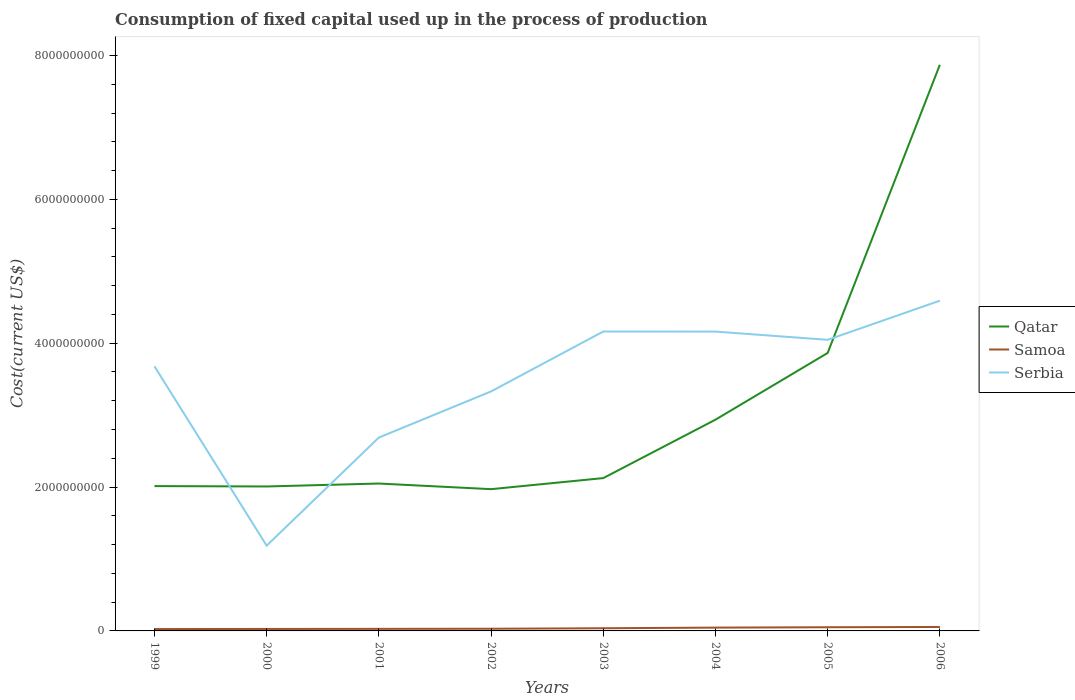Is the number of lines equal to the number of legend labels?
Make the answer very short. Yes. Across all years, what is the maximum amount consumed in the process of production in Samoa?
Offer a very short reply. 2.60e+07. In which year was the amount consumed in the process of production in Qatar maximum?
Make the answer very short. 2002. What is the total amount consumed in the process of production in Qatar in the graph?
Give a very brief answer. 4.26e+07. What is the difference between the highest and the second highest amount consumed in the process of production in Samoa?
Provide a succinct answer. 2.90e+07. What is the difference between the highest and the lowest amount consumed in the process of production in Serbia?
Keep it short and to the point. 5. Is the amount consumed in the process of production in Samoa strictly greater than the amount consumed in the process of production in Serbia over the years?
Provide a short and direct response. Yes. How many years are there in the graph?
Give a very brief answer. 8. Are the values on the major ticks of Y-axis written in scientific E-notation?
Your answer should be very brief. No. What is the title of the graph?
Give a very brief answer. Consumption of fixed capital used up in the process of production. Does "Ukraine" appear as one of the legend labels in the graph?
Your answer should be compact. No. What is the label or title of the Y-axis?
Give a very brief answer. Cost(current US$). What is the Cost(current US$) of Qatar in 1999?
Offer a very short reply. 2.01e+09. What is the Cost(current US$) in Samoa in 1999?
Your answer should be very brief. 2.60e+07. What is the Cost(current US$) in Serbia in 1999?
Offer a very short reply. 3.68e+09. What is the Cost(current US$) of Qatar in 2000?
Your response must be concise. 2.01e+09. What is the Cost(current US$) of Samoa in 2000?
Offer a terse response. 2.71e+07. What is the Cost(current US$) in Serbia in 2000?
Your response must be concise. 1.19e+09. What is the Cost(current US$) in Qatar in 2001?
Offer a terse response. 2.05e+09. What is the Cost(current US$) of Samoa in 2001?
Provide a succinct answer. 2.86e+07. What is the Cost(current US$) in Serbia in 2001?
Offer a terse response. 2.69e+09. What is the Cost(current US$) in Qatar in 2002?
Provide a short and direct response. 1.97e+09. What is the Cost(current US$) of Samoa in 2002?
Ensure brevity in your answer.  3.05e+07. What is the Cost(current US$) in Serbia in 2002?
Your response must be concise. 3.33e+09. What is the Cost(current US$) of Qatar in 2003?
Your response must be concise. 2.12e+09. What is the Cost(current US$) in Samoa in 2003?
Keep it short and to the point. 3.71e+07. What is the Cost(current US$) in Serbia in 2003?
Offer a terse response. 4.16e+09. What is the Cost(current US$) of Qatar in 2004?
Ensure brevity in your answer.  2.94e+09. What is the Cost(current US$) in Samoa in 2004?
Give a very brief answer. 4.61e+07. What is the Cost(current US$) in Serbia in 2004?
Provide a short and direct response. 4.16e+09. What is the Cost(current US$) of Qatar in 2005?
Offer a very short reply. 3.86e+09. What is the Cost(current US$) in Samoa in 2005?
Provide a succinct answer. 5.10e+07. What is the Cost(current US$) in Serbia in 2005?
Provide a short and direct response. 4.05e+09. What is the Cost(current US$) of Qatar in 2006?
Your answer should be compact. 7.87e+09. What is the Cost(current US$) of Samoa in 2006?
Your answer should be compact. 5.49e+07. What is the Cost(current US$) of Serbia in 2006?
Your answer should be very brief. 4.59e+09. Across all years, what is the maximum Cost(current US$) in Qatar?
Offer a very short reply. 7.87e+09. Across all years, what is the maximum Cost(current US$) of Samoa?
Ensure brevity in your answer.  5.49e+07. Across all years, what is the maximum Cost(current US$) in Serbia?
Make the answer very short. 4.59e+09. Across all years, what is the minimum Cost(current US$) of Qatar?
Give a very brief answer. 1.97e+09. Across all years, what is the minimum Cost(current US$) of Samoa?
Keep it short and to the point. 2.60e+07. Across all years, what is the minimum Cost(current US$) in Serbia?
Offer a very short reply. 1.19e+09. What is the total Cost(current US$) in Qatar in the graph?
Provide a succinct answer. 2.48e+1. What is the total Cost(current US$) of Samoa in the graph?
Provide a succinct answer. 3.01e+08. What is the total Cost(current US$) of Serbia in the graph?
Ensure brevity in your answer.  2.78e+1. What is the difference between the Cost(current US$) of Qatar in 1999 and that in 2000?
Give a very brief answer. 5.22e+06. What is the difference between the Cost(current US$) of Samoa in 1999 and that in 2000?
Ensure brevity in your answer.  -1.17e+06. What is the difference between the Cost(current US$) in Serbia in 1999 and that in 2000?
Make the answer very short. 2.49e+09. What is the difference between the Cost(current US$) of Qatar in 1999 and that in 2001?
Make the answer very short. -3.57e+07. What is the difference between the Cost(current US$) in Samoa in 1999 and that in 2001?
Your response must be concise. -2.62e+06. What is the difference between the Cost(current US$) in Serbia in 1999 and that in 2001?
Offer a terse response. 9.90e+08. What is the difference between the Cost(current US$) in Qatar in 1999 and that in 2002?
Offer a very short reply. 4.26e+07. What is the difference between the Cost(current US$) of Samoa in 1999 and that in 2002?
Your answer should be very brief. -4.53e+06. What is the difference between the Cost(current US$) in Serbia in 1999 and that in 2002?
Your response must be concise. 3.50e+08. What is the difference between the Cost(current US$) in Qatar in 1999 and that in 2003?
Provide a succinct answer. -1.11e+08. What is the difference between the Cost(current US$) in Samoa in 1999 and that in 2003?
Offer a very short reply. -1.11e+07. What is the difference between the Cost(current US$) of Serbia in 1999 and that in 2003?
Provide a short and direct response. -4.84e+08. What is the difference between the Cost(current US$) of Qatar in 1999 and that in 2004?
Give a very brief answer. -9.23e+08. What is the difference between the Cost(current US$) in Samoa in 1999 and that in 2004?
Give a very brief answer. -2.02e+07. What is the difference between the Cost(current US$) of Serbia in 1999 and that in 2004?
Make the answer very short. -4.83e+08. What is the difference between the Cost(current US$) of Qatar in 1999 and that in 2005?
Offer a very short reply. -1.85e+09. What is the difference between the Cost(current US$) of Samoa in 1999 and that in 2005?
Make the answer very short. -2.51e+07. What is the difference between the Cost(current US$) of Serbia in 1999 and that in 2005?
Ensure brevity in your answer.  -3.68e+08. What is the difference between the Cost(current US$) of Qatar in 1999 and that in 2006?
Offer a very short reply. -5.86e+09. What is the difference between the Cost(current US$) in Samoa in 1999 and that in 2006?
Give a very brief answer. -2.90e+07. What is the difference between the Cost(current US$) of Serbia in 1999 and that in 2006?
Your answer should be compact. -9.12e+08. What is the difference between the Cost(current US$) in Qatar in 2000 and that in 2001?
Your response must be concise. -4.09e+07. What is the difference between the Cost(current US$) of Samoa in 2000 and that in 2001?
Provide a succinct answer. -1.45e+06. What is the difference between the Cost(current US$) in Serbia in 2000 and that in 2001?
Offer a very short reply. -1.50e+09. What is the difference between the Cost(current US$) of Qatar in 2000 and that in 2002?
Your response must be concise. 3.74e+07. What is the difference between the Cost(current US$) in Samoa in 2000 and that in 2002?
Provide a succinct answer. -3.36e+06. What is the difference between the Cost(current US$) in Serbia in 2000 and that in 2002?
Your response must be concise. -2.14e+09. What is the difference between the Cost(current US$) of Qatar in 2000 and that in 2003?
Offer a very short reply. -1.16e+08. What is the difference between the Cost(current US$) in Samoa in 2000 and that in 2003?
Your answer should be very brief. -9.98e+06. What is the difference between the Cost(current US$) of Serbia in 2000 and that in 2003?
Your answer should be compact. -2.98e+09. What is the difference between the Cost(current US$) in Qatar in 2000 and that in 2004?
Offer a very short reply. -9.29e+08. What is the difference between the Cost(current US$) of Samoa in 2000 and that in 2004?
Give a very brief answer. -1.90e+07. What is the difference between the Cost(current US$) of Serbia in 2000 and that in 2004?
Offer a terse response. -2.98e+09. What is the difference between the Cost(current US$) of Qatar in 2000 and that in 2005?
Offer a terse response. -1.86e+09. What is the difference between the Cost(current US$) of Samoa in 2000 and that in 2005?
Give a very brief answer. -2.39e+07. What is the difference between the Cost(current US$) of Serbia in 2000 and that in 2005?
Offer a terse response. -2.86e+09. What is the difference between the Cost(current US$) in Qatar in 2000 and that in 2006?
Keep it short and to the point. -5.86e+09. What is the difference between the Cost(current US$) in Samoa in 2000 and that in 2006?
Offer a very short reply. -2.78e+07. What is the difference between the Cost(current US$) in Serbia in 2000 and that in 2006?
Your response must be concise. -3.41e+09. What is the difference between the Cost(current US$) of Qatar in 2001 and that in 2002?
Ensure brevity in your answer.  7.83e+07. What is the difference between the Cost(current US$) of Samoa in 2001 and that in 2002?
Ensure brevity in your answer.  -1.91e+06. What is the difference between the Cost(current US$) in Serbia in 2001 and that in 2002?
Provide a short and direct response. -6.41e+08. What is the difference between the Cost(current US$) in Qatar in 2001 and that in 2003?
Provide a succinct answer. -7.55e+07. What is the difference between the Cost(current US$) in Samoa in 2001 and that in 2003?
Provide a succinct answer. -8.53e+06. What is the difference between the Cost(current US$) in Serbia in 2001 and that in 2003?
Make the answer very short. -1.47e+09. What is the difference between the Cost(current US$) in Qatar in 2001 and that in 2004?
Your response must be concise. -8.88e+08. What is the difference between the Cost(current US$) of Samoa in 2001 and that in 2004?
Provide a short and direct response. -1.76e+07. What is the difference between the Cost(current US$) in Serbia in 2001 and that in 2004?
Your response must be concise. -1.47e+09. What is the difference between the Cost(current US$) of Qatar in 2001 and that in 2005?
Make the answer very short. -1.82e+09. What is the difference between the Cost(current US$) of Samoa in 2001 and that in 2005?
Your answer should be very brief. -2.24e+07. What is the difference between the Cost(current US$) in Serbia in 2001 and that in 2005?
Provide a short and direct response. -1.36e+09. What is the difference between the Cost(current US$) of Qatar in 2001 and that in 2006?
Make the answer very short. -5.82e+09. What is the difference between the Cost(current US$) of Samoa in 2001 and that in 2006?
Ensure brevity in your answer.  -2.64e+07. What is the difference between the Cost(current US$) in Serbia in 2001 and that in 2006?
Your response must be concise. -1.90e+09. What is the difference between the Cost(current US$) in Qatar in 2002 and that in 2003?
Keep it short and to the point. -1.54e+08. What is the difference between the Cost(current US$) of Samoa in 2002 and that in 2003?
Give a very brief answer. -6.62e+06. What is the difference between the Cost(current US$) of Serbia in 2002 and that in 2003?
Provide a succinct answer. -8.33e+08. What is the difference between the Cost(current US$) in Qatar in 2002 and that in 2004?
Your answer should be very brief. -9.66e+08. What is the difference between the Cost(current US$) in Samoa in 2002 and that in 2004?
Offer a terse response. -1.56e+07. What is the difference between the Cost(current US$) of Serbia in 2002 and that in 2004?
Your answer should be compact. -8.32e+08. What is the difference between the Cost(current US$) of Qatar in 2002 and that in 2005?
Offer a very short reply. -1.89e+09. What is the difference between the Cost(current US$) in Samoa in 2002 and that in 2005?
Keep it short and to the point. -2.05e+07. What is the difference between the Cost(current US$) in Serbia in 2002 and that in 2005?
Give a very brief answer. -7.18e+08. What is the difference between the Cost(current US$) of Qatar in 2002 and that in 2006?
Your answer should be very brief. -5.90e+09. What is the difference between the Cost(current US$) in Samoa in 2002 and that in 2006?
Your answer should be very brief. -2.44e+07. What is the difference between the Cost(current US$) of Serbia in 2002 and that in 2006?
Ensure brevity in your answer.  -1.26e+09. What is the difference between the Cost(current US$) of Qatar in 2003 and that in 2004?
Your response must be concise. -8.12e+08. What is the difference between the Cost(current US$) of Samoa in 2003 and that in 2004?
Give a very brief answer. -9.02e+06. What is the difference between the Cost(current US$) of Serbia in 2003 and that in 2004?
Make the answer very short. 1.14e+06. What is the difference between the Cost(current US$) of Qatar in 2003 and that in 2005?
Your response must be concise. -1.74e+09. What is the difference between the Cost(current US$) of Samoa in 2003 and that in 2005?
Your answer should be very brief. -1.39e+07. What is the difference between the Cost(current US$) of Serbia in 2003 and that in 2005?
Your answer should be very brief. 1.16e+08. What is the difference between the Cost(current US$) of Qatar in 2003 and that in 2006?
Your answer should be compact. -5.75e+09. What is the difference between the Cost(current US$) in Samoa in 2003 and that in 2006?
Your response must be concise. -1.78e+07. What is the difference between the Cost(current US$) of Serbia in 2003 and that in 2006?
Your response must be concise. -4.28e+08. What is the difference between the Cost(current US$) in Qatar in 2004 and that in 2005?
Your answer should be very brief. -9.28e+08. What is the difference between the Cost(current US$) of Samoa in 2004 and that in 2005?
Your response must be concise. -4.88e+06. What is the difference between the Cost(current US$) of Serbia in 2004 and that in 2005?
Offer a very short reply. 1.14e+08. What is the difference between the Cost(current US$) in Qatar in 2004 and that in 2006?
Provide a succinct answer. -4.93e+09. What is the difference between the Cost(current US$) of Samoa in 2004 and that in 2006?
Provide a succinct answer. -8.80e+06. What is the difference between the Cost(current US$) in Serbia in 2004 and that in 2006?
Provide a short and direct response. -4.30e+08. What is the difference between the Cost(current US$) in Qatar in 2005 and that in 2006?
Ensure brevity in your answer.  -4.01e+09. What is the difference between the Cost(current US$) in Samoa in 2005 and that in 2006?
Provide a succinct answer. -3.92e+06. What is the difference between the Cost(current US$) in Serbia in 2005 and that in 2006?
Give a very brief answer. -5.44e+08. What is the difference between the Cost(current US$) in Qatar in 1999 and the Cost(current US$) in Samoa in 2000?
Your answer should be very brief. 1.99e+09. What is the difference between the Cost(current US$) in Qatar in 1999 and the Cost(current US$) in Serbia in 2000?
Give a very brief answer. 8.28e+08. What is the difference between the Cost(current US$) in Samoa in 1999 and the Cost(current US$) in Serbia in 2000?
Your answer should be very brief. -1.16e+09. What is the difference between the Cost(current US$) in Qatar in 1999 and the Cost(current US$) in Samoa in 2001?
Offer a very short reply. 1.98e+09. What is the difference between the Cost(current US$) in Qatar in 1999 and the Cost(current US$) in Serbia in 2001?
Provide a short and direct response. -6.75e+08. What is the difference between the Cost(current US$) of Samoa in 1999 and the Cost(current US$) of Serbia in 2001?
Your response must be concise. -2.66e+09. What is the difference between the Cost(current US$) in Qatar in 1999 and the Cost(current US$) in Samoa in 2002?
Your answer should be very brief. 1.98e+09. What is the difference between the Cost(current US$) in Qatar in 1999 and the Cost(current US$) in Serbia in 2002?
Provide a short and direct response. -1.32e+09. What is the difference between the Cost(current US$) in Samoa in 1999 and the Cost(current US$) in Serbia in 2002?
Ensure brevity in your answer.  -3.30e+09. What is the difference between the Cost(current US$) in Qatar in 1999 and the Cost(current US$) in Samoa in 2003?
Keep it short and to the point. 1.98e+09. What is the difference between the Cost(current US$) in Qatar in 1999 and the Cost(current US$) in Serbia in 2003?
Your answer should be compact. -2.15e+09. What is the difference between the Cost(current US$) in Samoa in 1999 and the Cost(current US$) in Serbia in 2003?
Your response must be concise. -4.14e+09. What is the difference between the Cost(current US$) of Qatar in 1999 and the Cost(current US$) of Samoa in 2004?
Provide a succinct answer. 1.97e+09. What is the difference between the Cost(current US$) of Qatar in 1999 and the Cost(current US$) of Serbia in 2004?
Offer a terse response. -2.15e+09. What is the difference between the Cost(current US$) in Samoa in 1999 and the Cost(current US$) in Serbia in 2004?
Your answer should be very brief. -4.14e+09. What is the difference between the Cost(current US$) in Qatar in 1999 and the Cost(current US$) in Samoa in 2005?
Your answer should be very brief. 1.96e+09. What is the difference between the Cost(current US$) in Qatar in 1999 and the Cost(current US$) in Serbia in 2005?
Make the answer very short. -2.03e+09. What is the difference between the Cost(current US$) in Samoa in 1999 and the Cost(current US$) in Serbia in 2005?
Keep it short and to the point. -4.02e+09. What is the difference between the Cost(current US$) in Qatar in 1999 and the Cost(current US$) in Samoa in 2006?
Your answer should be compact. 1.96e+09. What is the difference between the Cost(current US$) in Qatar in 1999 and the Cost(current US$) in Serbia in 2006?
Your response must be concise. -2.58e+09. What is the difference between the Cost(current US$) in Samoa in 1999 and the Cost(current US$) in Serbia in 2006?
Offer a very short reply. -4.57e+09. What is the difference between the Cost(current US$) of Qatar in 2000 and the Cost(current US$) of Samoa in 2001?
Provide a succinct answer. 1.98e+09. What is the difference between the Cost(current US$) of Qatar in 2000 and the Cost(current US$) of Serbia in 2001?
Ensure brevity in your answer.  -6.80e+08. What is the difference between the Cost(current US$) of Samoa in 2000 and the Cost(current US$) of Serbia in 2001?
Your answer should be very brief. -2.66e+09. What is the difference between the Cost(current US$) of Qatar in 2000 and the Cost(current US$) of Samoa in 2002?
Keep it short and to the point. 1.98e+09. What is the difference between the Cost(current US$) in Qatar in 2000 and the Cost(current US$) in Serbia in 2002?
Offer a very short reply. -1.32e+09. What is the difference between the Cost(current US$) of Samoa in 2000 and the Cost(current US$) of Serbia in 2002?
Provide a succinct answer. -3.30e+09. What is the difference between the Cost(current US$) of Qatar in 2000 and the Cost(current US$) of Samoa in 2003?
Your answer should be very brief. 1.97e+09. What is the difference between the Cost(current US$) of Qatar in 2000 and the Cost(current US$) of Serbia in 2003?
Make the answer very short. -2.15e+09. What is the difference between the Cost(current US$) of Samoa in 2000 and the Cost(current US$) of Serbia in 2003?
Your answer should be very brief. -4.14e+09. What is the difference between the Cost(current US$) of Qatar in 2000 and the Cost(current US$) of Samoa in 2004?
Ensure brevity in your answer.  1.96e+09. What is the difference between the Cost(current US$) of Qatar in 2000 and the Cost(current US$) of Serbia in 2004?
Provide a succinct answer. -2.15e+09. What is the difference between the Cost(current US$) in Samoa in 2000 and the Cost(current US$) in Serbia in 2004?
Provide a succinct answer. -4.13e+09. What is the difference between the Cost(current US$) in Qatar in 2000 and the Cost(current US$) in Samoa in 2005?
Offer a terse response. 1.96e+09. What is the difference between the Cost(current US$) of Qatar in 2000 and the Cost(current US$) of Serbia in 2005?
Your answer should be very brief. -2.04e+09. What is the difference between the Cost(current US$) in Samoa in 2000 and the Cost(current US$) in Serbia in 2005?
Make the answer very short. -4.02e+09. What is the difference between the Cost(current US$) in Qatar in 2000 and the Cost(current US$) in Samoa in 2006?
Make the answer very short. 1.95e+09. What is the difference between the Cost(current US$) of Qatar in 2000 and the Cost(current US$) of Serbia in 2006?
Keep it short and to the point. -2.58e+09. What is the difference between the Cost(current US$) in Samoa in 2000 and the Cost(current US$) in Serbia in 2006?
Keep it short and to the point. -4.56e+09. What is the difference between the Cost(current US$) of Qatar in 2001 and the Cost(current US$) of Samoa in 2002?
Make the answer very short. 2.02e+09. What is the difference between the Cost(current US$) of Qatar in 2001 and the Cost(current US$) of Serbia in 2002?
Your response must be concise. -1.28e+09. What is the difference between the Cost(current US$) in Samoa in 2001 and the Cost(current US$) in Serbia in 2002?
Make the answer very short. -3.30e+09. What is the difference between the Cost(current US$) in Qatar in 2001 and the Cost(current US$) in Samoa in 2003?
Offer a very short reply. 2.01e+09. What is the difference between the Cost(current US$) in Qatar in 2001 and the Cost(current US$) in Serbia in 2003?
Offer a very short reply. -2.11e+09. What is the difference between the Cost(current US$) in Samoa in 2001 and the Cost(current US$) in Serbia in 2003?
Your answer should be very brief. -4.13e+09. What is the difference between the Cost(current US$) of Qatar in 2001 and the Cost(current US$) of Samoa in 2004?
Offer a terse response. 2.00e+09. What is the difference between the Cost(current US$) of Qatar in 2001 and the Cost(current US$) of Serbia in 2004?
Your response must be concise. -2.11e+09. What is the difference between the Cost(current US$) of Samoa in 2001 and the Cost(current US$) of Serbia in 2004?
Your response must be concise. -4.13e+09. What is the difference between the Cost(current US$) of Qatar in 2001 and the Cost(current US$) of Samoa in 2005?
Your answer should be very brief. 2.00e+09. What is the difference between the Cost(current US$) of Qatar in 2001 and the Cost(current US$) of Serbia in 2005?
Your answer should be compact. -2.00e+09. What is the difference between the Cost(current US$) in Samoa in 2001 and the Cost(current US$) in Serbia in 2005?
Your response must be concise. -4.02e+09. What is the difference between the Cost(current US$) in Qatar in 2001 and the Cost(current US$) in Samoa in 2006?
Your response must be concise. 1.99e+09. What is the difference between the Cost(current US$) in Qatar in 2001 and the Cost(current US$) in Serbia in 2006?
Make the answer very short. -2.54e+09. What is the difference between the Cost(current US$) of Samoa in 2001 and the Cost(current US$) of Serbia in 2006?
Ensure brevity in your answer.  -4.56e+09. What is the difference between the Cost(current US$) of Qatar in 2002 and the Cost(current US$) of Samoa in 2003?
Provide a short and direct response. 1.93e+09. What is the difference between the Cost(current US$) in Qatar in 2002 and the Cost(current US$) in Serbia in 2003?
Your answer should be very brief. -2.19e+09. What is the difference between the Cost(current US$) in Samoa in 2002 and the Cost(current US$) in Serbia in 2003?
Provide a succinct answer. -4.13e+09. What is the difference between the Cost(current US$) in Qatar in 2002 and the Cost(current US$) in Samoa in 2004?
Your response must be concise. 1.92e+09. What is the difference between the Cost(current US$) of Qatar in 2002 and the Cost(current US$) of Serbia in 2004?
Your answer should be compact. -2.19e+09. What is the difference between the Cost(current US$) in Samoa in 2002 and the Cost(current US$) in Serbia in 2004?
Offer a terse response. -4.13e+09. What is the difference between the Cost(current US$) of Qatar in 2002 and the Cost(current US$) of Samoa in 2005?
Your answer should be compact. 1.92e+09. What is the difference between the Cost(current US$) of Qatar in 2002 and the Cost(current US$) of Serbia in 2005?
Offer a terse response. -2.08e+09. What is the difference between the Cost(current US$) of Samoa in 2002 and the Cost(current US$) of Serbia in 2005?
Provide a succinct answer. -4.02e+09. What is the difference between the Cost(current US$) of Qatar in 2002 and the Cost(current US$) of Samoa in 2006?
Offer a very short reply. 1.92e+09. What is the difference between the Cost(current US$) of Qatar in 2002 and the Cost(current US$) of Serbia in 2006?
Give a very brief answer. -2.62e+09. What is the difference between the Cost(current US$) of Samoa in 2002 and the Cost(current US$) of Serbia in 2006?
Your answer should be compact. -4.56e+09. What is the difference between the Cost(current US$) in Qatar in 2003 and the Cost(current US$) in Samoa in 2004?
Provide a short and direct response. 2.08e+09. What is the difference between the Cost(current US$) in Qatar in 2003 and the Cost(current US$) in Serbia in 2004?
Give a very brief answer. -2.04e+09. What is the difference between the Cost(current US$) in Samoa in 2003 and the Cost(current US$) in Serbia in 2004?
Keep it short and to the point. -4.12e+09. What is the difference between the Cost(current US$) in Qatar in 2003 and the Cost(current US$) in Samoa in 2005?
Keep it short and to the point. 2.07e+09. What is the difference between the Cost(current US$) of Qatar in 2003 and the Cost(current US$) of Serbia in 2005?
Give a very brief answer. -1.92e+09. What is the difference between the Cost(current US$) of Samoa in 2003 and the Cost(current US$) of Serbia in 2005?
Your response must be concise. -4.01e+09. What is the difference between the Cost(current US$) of Qatar in 2003 and the Cost(current US$) of Samoa in 2006?
Provide a short and direct response. 2.07e+09. What is the difference between the Cost(current US$) of Qatar in 2003 and the Cost(current US$) of Serbia in 2006?
Provide a succinct answer. -2.47e+09. What is the difference between the Cost(current US$) in Samoa in 2003 and the Cost(current US$) in Serbia in 2006?
Provide a succinct answer. -4.55e+09. What is the difference between the Cost(current US$) of Qatar in 2004 and the Cost(current US$) of Samoa in 2005?
Your response must be concise. 2.89e+09. What is the difference between the Cost(current US$) in Qatar in 2004 and the Cost(current US$) in Serbia in 2005?
Offer a very short reply. -1.11e+09. What is the difference between the Cost(current US$) in Samoa in 2004 and the Cost(current US$) in Serbia in 2005?
Your answer should be compact. -4.00e+09. What is the difference between the Cost(current US$) in Qatar in 2004 and the Cost(current US$) in Samoa in 2006?
Make the answer very short. 2.88e+09. What is the difference between the Cost(current US$) of Qatar in 2004 and the Cost(current US$) of Serbia in 2006?
Provide a succinct answer. -1.65e+09. What is the difference between the Cost(current US$) in Samoa in 2004 and the Cost(current US$) in Serbia in 2006?
Make the answer very short. -4.55e+09. What is the difference between the Cost(current US$) in Qatar in 2005 and the Cost(current US$) in Samoa in 2006?
Make the answer very short. 3.81e+09. What is the difference between the Cost(current US$) of Qatar in 2005 and the Cost(current US$) of Serbia in 2006?
Provide a succinct answer. -7.27e+08. What is the difference between the Cost(current US$) in Samoa in 2005 and the Cost(current US$) in Serbia in 2006?
Keep it short and to the point. -4.54e+09. What is the average Cost(current US$) of Qatar per year?
Your answer should be compact. 3.10e+09. What is the average Cost(current US$) in Samoa per year?
Give a very brief answer. 3.77e+07. What is the average Cost(current US$) in Serbia per year?
Offer a very short reply. 3.48e+09. In the year 1999, what is the difference between the Cost(current US$) of Qatar and Cost(current US$) of Samoa?
Give a very brief answer. 1.99e+09. In the year 1999, what is the difference between the Cost(current US$) in Qatar and Cost(current US$) in Serbia?
Your answer should be compact. -1.67e+09. In the year 1999, what is the difference between the Cost(current US$) of Samoa and Cost(current US$) of Serbia?
Provide a short and direct response. -3.65e+09. In the year 2000, what is the difference between the Cost(current US$) of Qatar and Cost(current US$) of Samoa?
Offer a very short reply. 1.98e+09. In the year 2000, what is the difference between the Cost(current US$) of Qatar and Cost(current US$) of Serbia?
Give a very brief answer. 8.23e+08. In the year 2000, what is the difference between the Cost(current US$) in Samoa and Cost(current US$) in Serbia?
Your response must be concise. -1.16e+09. In the year 2001, what is the difference between the Cost(current US$) of Qatar and Cost(current US$) of Samoa?
Provide a succinct answer. 2.02e+09. In the year 2001, what is the difference between the Cost(current US$) in Qatar and Cost(current US$) in Serbia?
Your answer should be compact. -6.39e+08. In the year 2001, what is the difference between the Cost(current US$) of Samoa and Cost(current US$) of Serbia?
Provide a succinct answer. -2.66e+09. In the year 2002, what is the difference between the Cost(current US$) in Qatar and Cost(current US$) in Samoa?
Provide a short and direct response. 1.94e+09. In the year 2002, what is the difference between the Cost(current US$) of Qatar and Cost(current US$) of Serbia?
Make the answer very short. -1.36e+09. In the year 2002, what is the difference between the Cost(current US$) in Samoa and Cost(current US$) in Serbia?
Offer a terse response. -3.30e+09. In the year 2003, what is the difference between the Cost(current US$) of Qatar and Cost(current US$) of Samoa?
Make the answer very short. 2.09e+09. In the year 2003, what is the difference between the Cost(current US$) in Qatar and Cost(current US$) in Serbia?
Give a very brief answer. -2.04e+09. In the year 2003, what is the difference between the Cost(current US$) in Samoa and Cost(current US$) in Serbia?
Offer a terse response. -4.13e+09. In the year 2004, what is the difference between the Cost(current US$) in Qatar and Cost(current US$) in Samoa?
Offer a terse response. 2.89e+09. In the year 2004, what is the difference between the Cost(current US$) of Qatar and Cost(current US$) of Serbia?
Your answer should be compact. -1.22e+09. In the year 2004, what is the difference between the Cost(current US$) in Samoa and Cost(current US$) in Serbia?
Offer a very short reply. -4.12e+09. In the year 2005, what is the difference between the Cost(current US$) of Qatar and Cost(current US$) of Samoa?
Provide a short and direct response. 3.81e+09. In the year 2005, what is the difference between the Cost(current US$) in Qatar and Cost(current US$) in Serbia?
Your response must be concise. -1.83e+08. In the year 2005, what is the difference between the Cost(current US$) in Samoa and Cost(current US$) in Serbia?
Your answer should be very brief. -4.00e+09. In the year 2006, what is the difference between the Cost(current US$) in Qatar and Cost(current US$) in Samoa?
Provide a succinct answer. 7.82e+09. In the year 2006, what is the difference between the Cost(current US$) in Qatar and Cost(current US$) in Serbia?
Give a very brief answer. 3.28e+09. In the year 2006, what is the difference between the Cost(current US$) of Samoa and Cost(current US$) of Serbia?
Your answer should be very brief. -4.54e+09. What is the ratio of the Cost(current US$) of Qatar in 1999 to that in 2000?
Your response must be concise. 1. What is the ratio of the Cost(current US$) in Samoa in 1999 to that in 2000?
Offer a terse response. 0.96. What is the ratio of the Cost(current US$) in Serbia in 1999 to that in 2000?
Your answer should be very brief. 3.1. What is the ratio of the Cost(current US$) of Qatar in 1999 to that in 2001?
Offer a very short reply. 0.98. What is the ratio of the Cost(current US$) in Samoa in 1999 to that in 2001?
Give a very brief answer. 0.91. What is the ratio of the Cost(current US$) in Serbia in 1999 to that in 2001?
Your response must be concise. 1.37. What is the ratio of the Cost(current US$) of Qatar in 1999 to that in 2002?
Your answer should be compact. 1.02. What is the ratio of the Cost(current US$) of Samoa in 1999 to that in 2002?
Offer a very short reply. 0.85. What is the ratio of the Cost(current US$) of Serbia in 1999 to that in 2002?
Give a very brief answer. 1.1. What is the ratio of the Cost(current US$) of Qatar in 1999 to that in 2003?
Offer a very short reply. 0.95. What is the ratio of the Cost(current US$) in Samoa in 1999 to that in 2003?
Offer a terse response. 0.7. What is the ratio of the Cost(current US$) of Serbia in 1999 to that in 2003?
Ensure brevity in your answer.  0.88. What is the ratio of the Cost(current US$) of Qatar in 1999 to that in 2004?
Ensure brevity in your answer.  0.69. What is the ratio of the Cost(current US$) of Samoa in 1999 to that in 2004?
Ensure brevity in your answer.  0.56. What is the ratio of the Cost(current US$) in Serbia in 1999 to that in 2004?
Offer a terse response. 0.88. What is the ratio of the Cost(current US$) of Qatar in 1999 to that in 2005?
Offer a very short reply. 0.52. What is the ratio of the Cost(current US$) in Samoa in 1999 to that in 2005?
Give a very brief answer. 0.51. What is the ratio of the Cost(current US$) of Serbia in 1999 to that in 2005?
Keep it short and to the point. 0.91. What is the ratio of the Cost(current US$) in Qatar in 1999 to that in 2006?
Ensure brevity in your answer.  0.26. What is the ratio of the Cost(current US$) in Samoa in 1999 to that in 2006?
Your answer should be very brief. 0.47. What is the ratio of the Cost(current US$) of Serbia in 1999 to that in 2006?
Keep it short and to the point. 0.8. What is the ratio of the Cost(current US$) of Samoa in 2000 to that in 2001?
Your answer should be very brief. 0.95. What is the ratio of the Cost(current US$) in Serbia in 2000 to that in 2001?
Ensure brevity in your answer.  0.44. What is the ratio of the Cost(current US$) in Qatar in 2000 to that in 2002?
Keep it short and to the point. 1.02. What is the ratio of the Cost(current US$) in Samoa in 2000 to that in 2002?
Keep it short and to the point. 0.89. What is the ratio of the Cost(current US$) of Serbia in 2000 to that in 2002?
Make the answer very short. 0.36. What is the ratio of the Cost(current US$) in Qatar in 2000 to that in 2003?
Your answer should be very brief. 0.95. What is the ratio of the Cost(current US$) in Samoa in 2000 to that in 2003?
Provide a succinct answer. 0.73. What is the ratio of the Cost(current US$) in Serbia in 2000 to that in 2003?
Keep it short and to the point. 0.28. What is the ratio of the Cost(current US$) of Qatar in 2000 to that in 2004?
Provide a succinct answer. 0.68. What is the ratio of the Cost(current US$) of Samoa in 2000 to that in 2004?
Keep it short and to the point. 0.59. What is the ratio of the Cost(current US$) in Serbia in 2000 to that in 2004?
Make the answer very short. 0.28. What is the ratio of the Cost(current US$) in Qatar in 2000 to that in 2005?
Your response must be concise. 0.52. What is the ratio of the Cost(current US$) of Samoa in 2000 to that in 2005?
Ensure brevity in your answer.  0.53. What is the ratio of the Cost(current US$) in Serbia in 2000 to that in 2005?
Your response must be concise. 0.29. What is the ratio of the Cost(current US$) in Qatar in 2000 to that in 2006?
Keep it short and to the point. 0.26. What is the ratio of the Cost(current US$) in Samoa in 2000 to that in 2006?
Make the answer very short. 0.49. What is the ratio of the Cost(current US$) in Serbia in 2000 to that in 2006?
Give a very brief answer. 0.26. What is the ratio of the Cost(current US$) of Qatar in 2001 to that in 2002?
Keep it short and to the point. 1.04. What is the ratio of the Cost(current US$) in Samoa in 2001 to that in 2002?
Offer a terse response. 0.94. What is the ratio of the Cost(current US$) in Serbia in 2001 to that in 2002?
Offer a very short reply. 0.81. What is the ratio of the Cost(current US$) of Qatar in 2001 to that in 2003?
Your answer should be compact. 0.96. What is the ratio of the Cost(current US$) of Samoa in 2001 to that in 2003?
Ensure brevity in your answer.  0.77. What is the ratio of the Cost(current US$) in Serbia in 2001 to that in 2003?
Offer a very short reply. 0.65. What is the ratio of the Cost(current US$) of Qatar in 2001 to that in 2004?
Ensure brevity in your answer.  0.7. What is the ratio of the Cost(current US$) in Samoa in 2001 to that in 2004?
Provide a short and direct response. 0.62. What is the ratio of the Cost(current US$) in Serbia in 2001 to that in 2004?
Make the answer very short. 0.65. What is the ratio of the Cost(current US$) in Qatar in 2001 to that in 2005?
Offer a terse response. 0.53. What is the ratio of the Cost(current US$) of Samoa in 2001 to that in 2005?
Your answer should be very brief. 0.56. What is the ratio of the Cost(current US$) of Serbia in 2001 to that in 2005?
Offer a very short reply. 0.66. What is the ratio of the Cost(current US$) in Qatar in 2001 to that in 2006?
Give a very brief answer. 0.26. What is the ratio of the Cost(current US$) in Samoa in 2001 to that in 2006?
Offer a very short reply. 0.52. What is the ratio of the Cost(current US$) of Serbia in 2001 to that in 2006?
Offer a terse response. 0.59. What is the ratio of the Cost(current US$) in Qatar in 2002 to that in 2003?
Give a very brief answer. 0.93. What is the ratio of the Cost(current US$) of Samoa in 2002 to that in 2003?
Offer a very short reply. 0.82. What is the ratio of the Cost(current US$) in Serbia in 2002 to that in 2003?
Offer a very short reply. 0.8. What is the ratio of the Cost(current US$) of Qatar in 2002 to that in 2004?
Offer a very short reply. 0.67. What is the ratio of the Cost(current US$) in Samoa in 2002 to that in 2004?
Provide a short and direct response. 0.66. What is the ratio of the Cost(current US$) of Serbia in 2002 to that in 2004?
Ensure brevity in your answer.  0.8. What is the ratio of the Cost(current US$) in Qatar in 2002 to that in 2005?
Your response must be concise. 0.51. What is the ratio of the Cost(current US$) of Samoa in 2002 to that in 2005?
Ensure brevity in your answer.  0.6. What is the ratio of the Cost(current US$) in Serbia in 2002 to that in 2005?
Your response must be concise. 0.82. What is the ratio of the Cost(current US$) in Qatar in 2002 to that in 2006?
Give a very brief answer. 0.25. What is the ratio of the Cost(current US$) of Samoa in 2002 to that in 2006?
Offer a very short reply. 0.56. What is the ratio of the Cost(current US$) of Serbia in 2002 to that in 2006?
Make the answer very short. 0.73. What is the ratio of the Cost(current US$) in Qatar in 2003 to that in 2004?
Provide a short and direct response. 0.72. What is the ratio of the Cost(current US$) in Samoa in 2003 to that in 2004?
Provide a short and direct response. 0.8. What is the ratio of the Cost(current US$) of Serbia in 2003 to that in 2004?
Keep it short and to the point. 1. What is the ratio of the Cost(current US$) in Qatar in 2003 to that in 2005?
Provide a short and direct response. 0.55. What is the ratio of the Cost(current US$) of Samoa in 2003 to that in 2005?
Provide a short and direct response. 0.73. What is the ratio of the Cost(current US$) of Serbia in 2003 to that in 2005?
Keep it short and to the point. 1.03. What is the ratio of the Cost(current US$) of Qatar in 2003 to that in 2006?
Provide a short and direct response. 0.27. What is the ratio of the Cost(current US$) of Samoa in 2003 to that in 2006?
Give a very brief answer. 0.68. What is the ratio of the Cost(current US$) of Serbia in 2003 to that in 2006?
Your response must be concise. 0.91. What is the ratio of the Cost(current US$) in Qatar in 2004 to that in 2005?
Offer a very short reply. 0.76. What is the ratio of the Cost(current US$) in Samoa in 2004 to that in 2005?
Give a very brief answer. 0.9. What is the ratio of the Cost(current US$) in Serbia in 2004 to that in 2005?
Offer a terse response. 1.03. What is the ratio of the Cost(current US$) of Qatar in 2004 to that in 2006?
Your answer should be very brief. 0.37. What is the ratio of the Cost(current US$) of Samoa in 2004 to that in 2006?
Keep it short and to the point. 0.84. What is the ratio of the Cost(current US$) of Serbia in 2004 to that in 2006?
Your answer should be very brief. 0.91. What is the ratio of the Cost(current US$) of Qatar in 2005 to that in 2006?
Make the answer very short. 0.49. What is the ratio of the Cost(current US$) in Samoa in 2005 to that in 2006?
Ensure brevity in your answer.  0.93. What is the ratio of the Cost(current US$) in Serbia in 2005 to that in 2006?
Your response must be concise. 0.88. What is the difference between the highest and the second highest Cost(current US$) in Qatar?
Offer a terse response. 4.01e+09. What is the difference between the highest and the second highest Cost(current US$) of Samoa?
Offer a terse response. 3.92e+06. What is the difference between the highest and the second highest Cost(current US$) in Serbia?
Make the answer very short. 4.28e+08. What is the difference between the highest and the lowest Cost(current US$) in Qatar?
Give a very brief answer. 5.90e+09. What is the difference between the highest and the lowest Cost(current US$) of Samoa?
Provide a short and direct response. 2.90e+07. What is the difference between the highest and the lowest Cost(current US$) of Serbia?
Your answer should be very brief. 3.41e+09. 